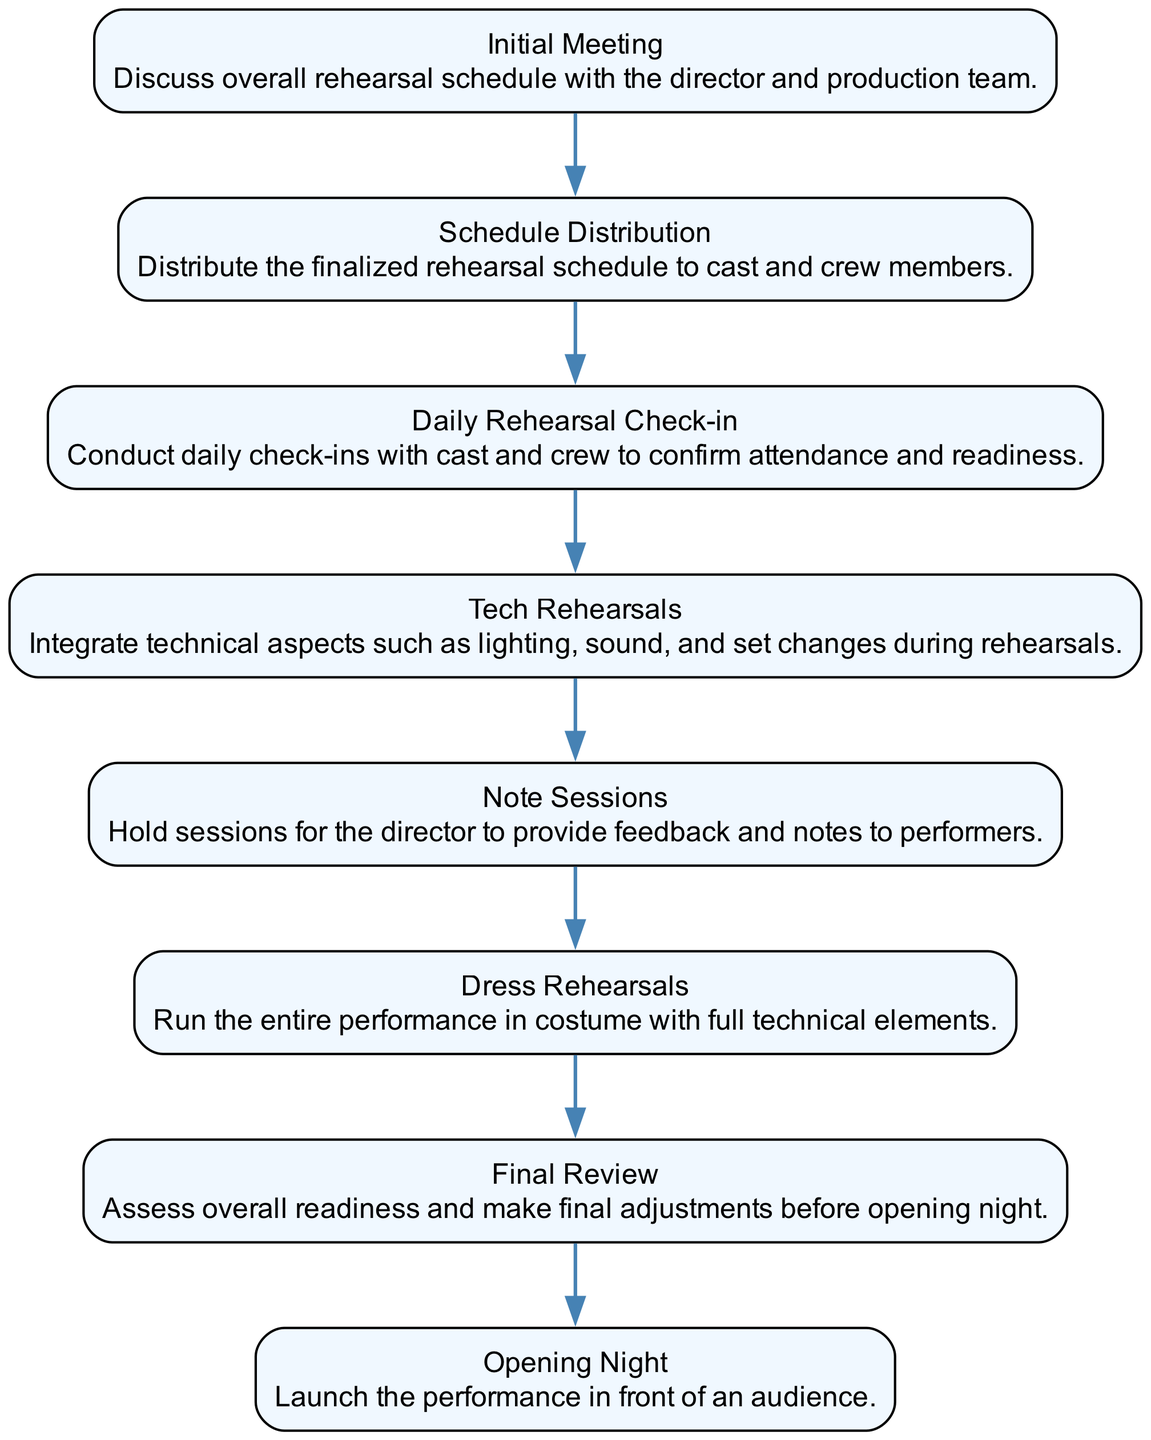What is the first step in the rehearsal process? The first step, as indicated by the top node in the flow chart, is the "Initial Meeting" where the overall rehearsal schedule is discussed.
Answer: Initial Meeting How many nodes are present in the diagram? By counting the number of distinct elements represented in the chart, we see that there are eight nodes related to the rehearsal schedule.
Answer: Eight What is the last step before the performance? The last step before the performance is "Final Review," where the overall readiness is assessed and adjustments made.
Answer: Final Review Which node follows the "Tech Rehearsals"? "Note Sessions" follows "Tech Rehearsals," as it is the next step in the progression outlined in the flow chart.
Answer: Note Sessions What type of rehearsal involves full technical elements? The type of rehearsal that involves full technical elements is "Dress Rehearsals," where the entire performance is run in costume.
Answer: Dress Rehearsals Which two nodes are directly connected? "Schedule Distribution" and "Daily Rehearsal Check-in" are directly connected, with the former leading into the latter in the flow of the rehearsal process.
Answer: Schedule Distribution and Daily Rehearsal Check-in What is the primary purpose of the "Note Sessions"? The primary purpose of the "Note Sessions" is to allow the director to provide feedback and notes to performers, which is crucial for their development.
Answer: Feedback and notes Which node marks the commencement of the performance? The commencement of the performance is marked by the "Opening Night," which is the final event in the flow chart sequence.
Answer: Opening Night 